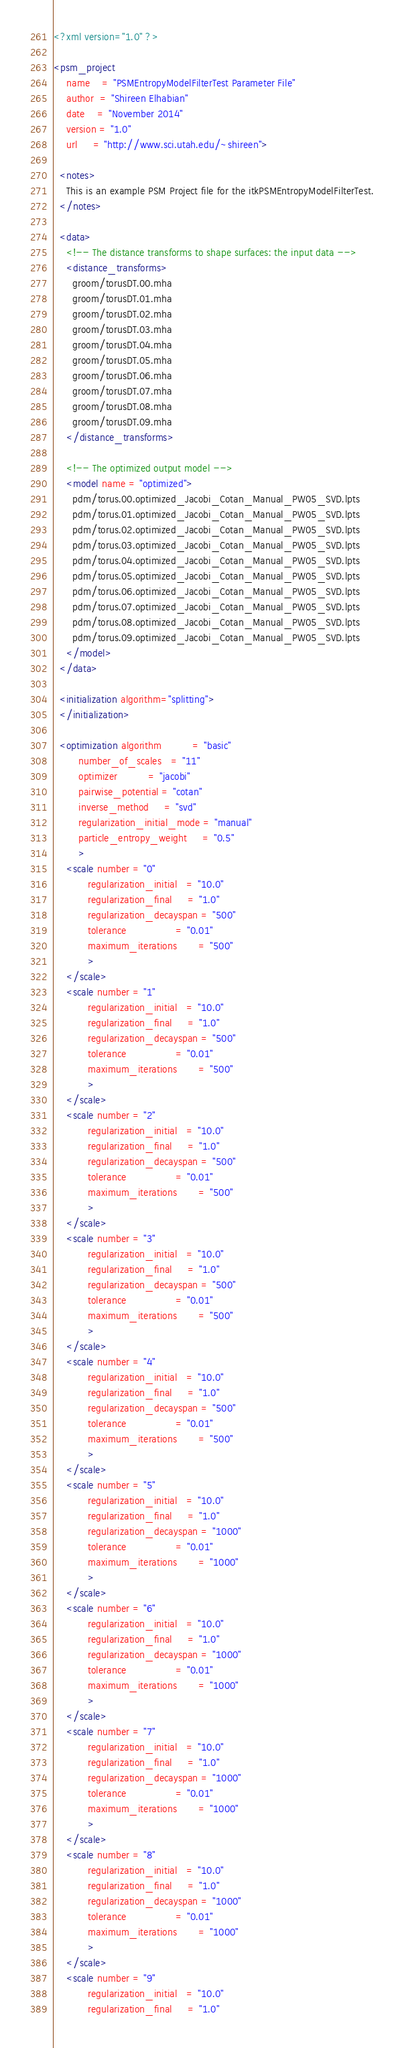<code> <loc_0><loc_0><loc_500><loc_500><_XML_><?xml version="1.0" ?>

<psm_project 
    name    = "PSMEntropyModelFilterTest Parameter File" 
    author  = "Shireen Elhabian" 
    date    = "November 2014" 
    version = "1.0" 
    url     = "http://www.sci.utah.edu/~shireen">

  <notes>
    This is an example PSM Project file for the itkPSMEntropyModelFilterTest.
  </notes>

  <data>
    <!-- The distance transforms to shape surfaces: the input data -->
    <distance_transforms>
      groom/torusDT.00.mha
      groom/torusDT.01.mha
      groom/torusDT.02.mha
      groom/torusDT.03.mha
      groom/torusDT.04.mha
      groom/torusDT.05.mha
      groom/torusDT.06.mha
      groom/torusDT.07.mha
      groom/torusDT.08.mha
      groom/torusDT.09.mha
    </distance_transforms>
    
    <!-- The optimized output model -->
    <model name = "optimized">
      pdm/torus.00.optimized_Jacobi_Cotan_Manual_PW05_SVD.lpts
      pdm/torus.01.optimized_Jacobi_Cotan_Manual_PW05_SVD.lpts
      pdm/torus.02.optimized_Jacobi_Cotan_Manual_PW05_SVD.lpts
      pdm/torus.03.optimized_Jacobi_Cotan_Manual_PW05_SVD.lpts
      pdm/torus.04.optimized_Jacobi_Cotan_Manual_PW05_SVD.lpts
      pdm/torus.05.optimized_Jacobi_Cotan_Manual_PW05_SVD.lpts
      pdm/torus.06.optimized_Jacobi_Cotan_Manual_PW05_SVD.lpts
      pdm/torus.07.optimized_Jacobi_Cotan_Manual_PW05_SVD.lpts
      pdm/torus.08.optimized_Jacobi_Cotan_Manual_PW05_SVD.lpts
      pdm/torus.09.optimized_Jacobi_Cotan_Manual_PW05_SVD.lpts
    </model>
  </data>
  
  <initialization algorithm="splitting">
  </initialization>
  
  <optimization algorithm          = "basic" 
		number_of_scales   = "11" 
		optimizer          = "jacobi" 
		pairwise_potential = "cotan"
		inverse_method     = "svd"
		regularization_initial_mode = "manual"
		particle_entropy_weight     = "0.5"
		>
    <scale number = "0"
           regularization_initial   = "10.0"
           regularization_final     = "1.0" 
           regularization_decayspan = "500"
           tolerance                = "0.01"
           maximum_iterations       = "500"
           >
    </scale>
    <scale number = "1"
           regularization_initial   = "10.0"
           regularization_final     = "1.0" 
           regularization_decayspan = "500"
           tolerance                = "0.01"
           maximum_iterations       = "500"
           >
    </scale>
    <scale number = "2"
           regularization_initial   = "10.0"
           regularization_final     = "1.0" 
           regularization_decayspan = "500"
           tolerance                = "0.01"
           maximum_iterations       = "500"
           >
    </scale>
    <scale number = "3"
           regularization_initial   = "10.0"
           regularization_final     = "1.0" 
           regularization_decayspan = "500"
           tolerance                = "0.01"
           maximum_iterations       = "500"
           >
    </scale>
    <scale number = "4"
           regularization_initial   = "10.0"
           regularization_final     = "1.0" 
           regularization_decayspan = "500"
           tolerance                = "0.01"
           maximum_iterations       = "500"
           >
    </scale>
    <scale number = "5"
           regularization_initial   = "10.0"
           regularization_final     = "1.0" 
           regularization_decayspan = "1000"
           tolerance                = "0.01"
           maximum_iterations       = "1000"
           >
    </scale>
    <scale number = "6"
           regularization_initial   = "10.0"
           regularization_final     = "1.0" 
           regularization_decayspan = "1000"
           tolerance                = "0.01"
           maximum_iterations       = "1000"
           >
    </scale>
    <scale number = "7"
           regularization_initial   = "10.0"
           regularization_final     = "1.0" 
           regularization_decayspan = "1000"
           tolerance                = "0.01"
           maximum_iterations       = "1000"
           >
    </scale>
    <scale number = "8"
           regularization_initial   = "10.0"
           regularization_final     = "1.0" 
           regularization_decayspan = "1000"
           tolerance                = "0.01"
           maximum_iterations       = "1000"
           >
    </scale>
    <scale number = "9"
           regularization_initial   = "10.0"
           regularization_final     = "1.0" </code> 